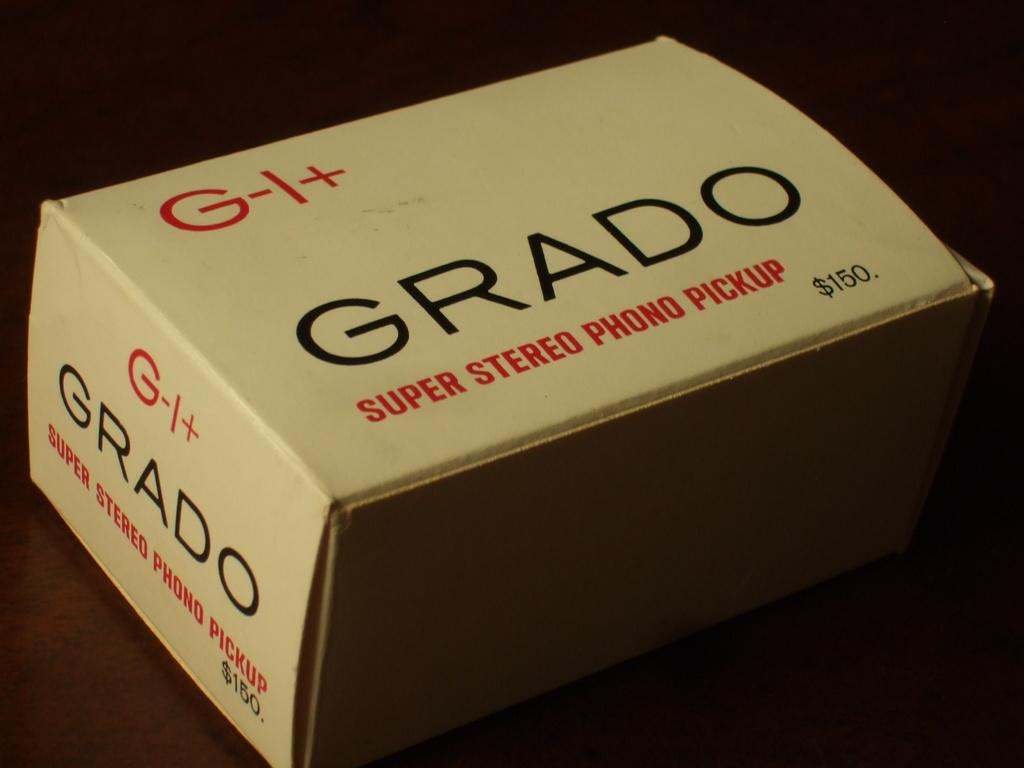<image>
Share a concise interpretation of the image provided. a small white box with black lettering that says 'grado' on it 